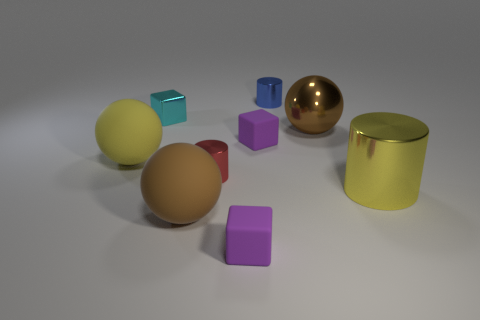Subtract all spheres. How many objects are left? 6 Subtract 1 blue cylinders. How many objects are left? 8 Subtract all small purple rubber blocks. Subtract all big things. How many objects are left? 3 Add 7 purple rubber things. How many purple rubber things are left? 9 Add 6 large rubber objects. How many large rubber objects exist? 8 